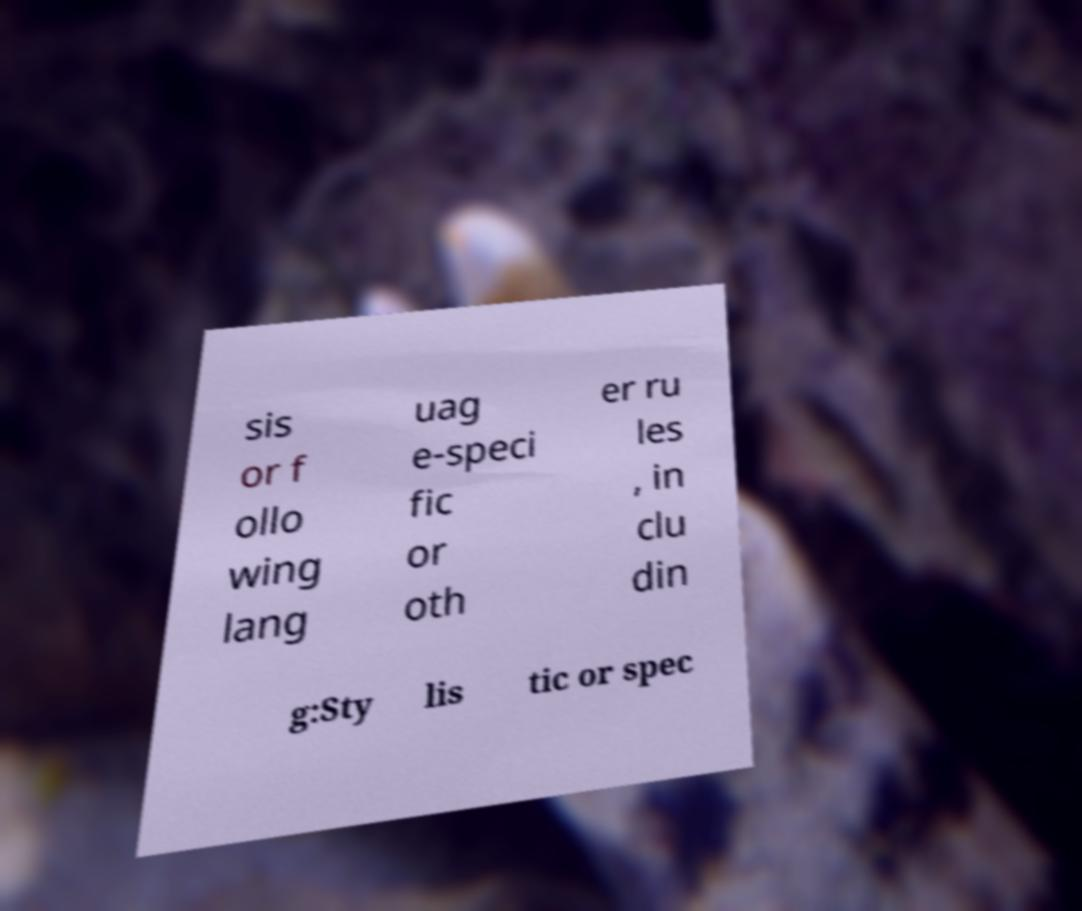Can you accurately transcribe the text from the provided image for me? sis or f ollo wing lang uag e-speci fic or oth er ru les , in clu din g:Sty lis tic or spec 